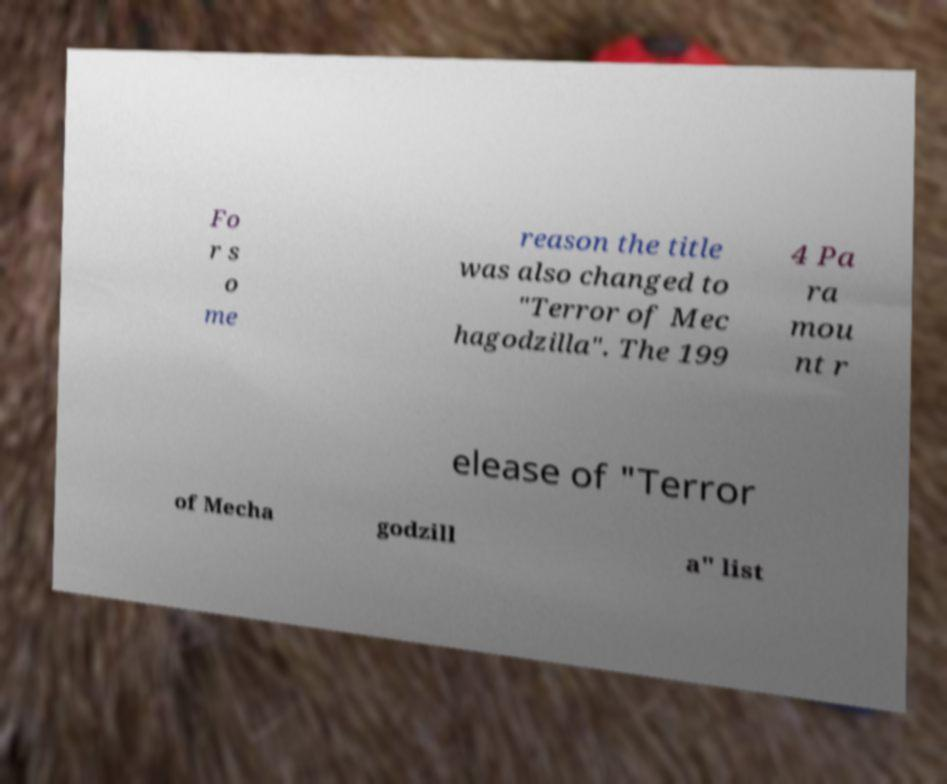Can you accurately transcribe the text from the provided image for me? Fo r s o me reason the title was also changed to "Terror of Mec hagodzilla". The 199 4 Pa ra mou nt r elease of "Terror of Mecha godzill a" list 